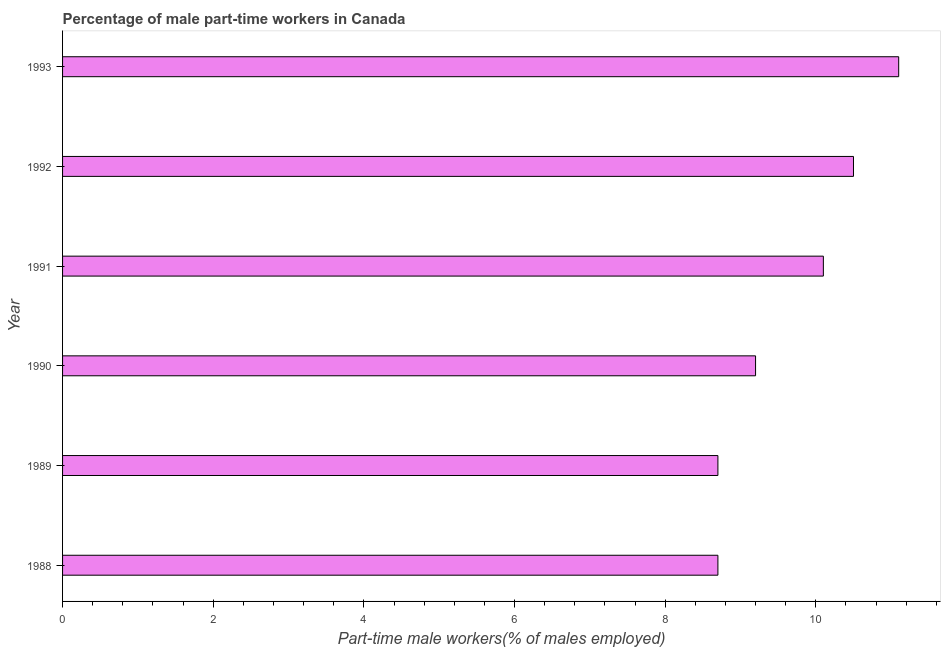What is the title of the graph?
Offer a very short reply. Percentage of male part-time workers in Canada. What is the label or title of the X-axis?
Your answer should be compact. Part-time male workers(% of males employed). What is the percentage of part-time male workers in 1988?
Ensure brevity in your answer.  8.7. Across all years, what is the maximum percentage of part-time male workers?
Your answer should be very brief. 11.1. Across all years, what is the minimum percentage of part-time male workers?
Make the answer very short. 8.7. What is the sum of the percentage of part-time male workers?
Provide a short and direct response. 58.3. What is the average percentage of part-time male workers per year?
Give a very brief answer. 9.72. What is the median percentage of part-time male workers?
Ensure brevity in your answer.  9.65. What is the ratio of the percentage of part-time male workers in 1989 to that in 1992?
Give a very brief answer. 0.83. Is the difference between the percentage of part-time male workers in 1992 and 1993 greater than the difference between any two years?
Provide a short and direct response. No. What is the difference between the highest and the second highest percentage of part-time male workers?
Offer a terse response. 0.6. How many bars are there?
Your answer should be very brief. 6. Are all the bars in the graph horizontal?
Ensure brevity in your answer.  Yes. How many years are there in the graph?
Provide a succinct answer. 6. Are the values on the major ticks of X-axis written in scientific E-notation?
Ensure brevity in your answer.  No. What is the Part-time male workers(% of males employed) in 1988?
Your answer should be compact. 8.7. What is the Part-time male workers(% of males employed) of 1989?
Offer a very short reply. 8.7. What is the Part-time male workers(% of males employed) in 1990?
Your answer should be compact. 9.2. What is the Part-time male workers(% of males employed) of 1991?
Provide a short and direct response. 10.1. What is the Part-time male workers(% of males employed) of 1992?
Keep it short and to the point. 10.5. What is the Part-time male workers(% of males employed) of 1993?
Offer a terse response. 11.1. What is the difference between the Part-time male workers(% of males employed) in 1989 and 1990?
Your answer should be very brief. -0.5. What is the difference between the Part-time male workers(% of males employed) in 1990 and 1992?
Offer a very short reply. -1.3. What is the difference between the Part-time male workers(% of males employed) in 1991 and 1992?
Make the answer very short. -0.4. What is the difference between the Part-time male workers(% of males employed) in 1992 and 1993?
Your answer should be very brief. -0.6. What is the ratio of the Part-time male workers(% of males employed) in 1988 to that in 1990?
Offer a terse response. 0.95. What is the ratio of the Part-time male workers(% of males employed) in 1988 to that in 1991?
Give a very brief answer. 0.86. What is the ratio of the Part-time male workers(% of males employed) in 1988 to that in 1992?
Offer a terse response. 0.83. What is the ratio of the Part-time male workers(% of males employed) in 1988 to that in 1993?
Keep it short and to the point. 0.78. What is the ratio of the Part-time male workers(% of males employed) in 1989 to that in 1990?
Provide a succinct answer. 0.95. What is the ratio of the Part-time male workers(% of males employed) in 1989 to that in 1991?
Make the answer very short. 0.86. What is the ratio of the Part-time male workers(% of males employed) in 1989 to that in 1992?
Keep it short and to the point. 0.83. What is the ratio of the Part-time male workers(% of males employed) in 1989 to that in 1993?
Your answer should be compact. 0.78. What is the ratio of the Part-time male workers(% of males employed) in 1990 to that in 1991?
Provide a short and direct response. 0.91. What is the ratio of the Part-time male workers(% of males employed) in 1990 to that in 1992?
Ensure brevity in your answer.  0.88. What is the ratio of the Part-time male workers(% of males employed) in 1990 to that in 1993?
Provide a short and direct response. 0.83. What is the ratio of the Part-time male workers(% of males employed) in 1991 to that in 1992?
Provide a short and direct response. 0.96. What is the ratio of the Part-time male workers(% of males employed) in 1991 to that in 1993?
Provide a succinct answer. 0.91. What is the ratio of the Part-time male workers(% of males employed) in 1992 to that in 1993?
Provide a short and direct response. 0.95. 